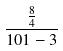<formula> <loc_0><loc_0><loc_500><loc_500>\frac { \frac { 8 } { 4 } } { 1 0 1 - 3 }</formula> 